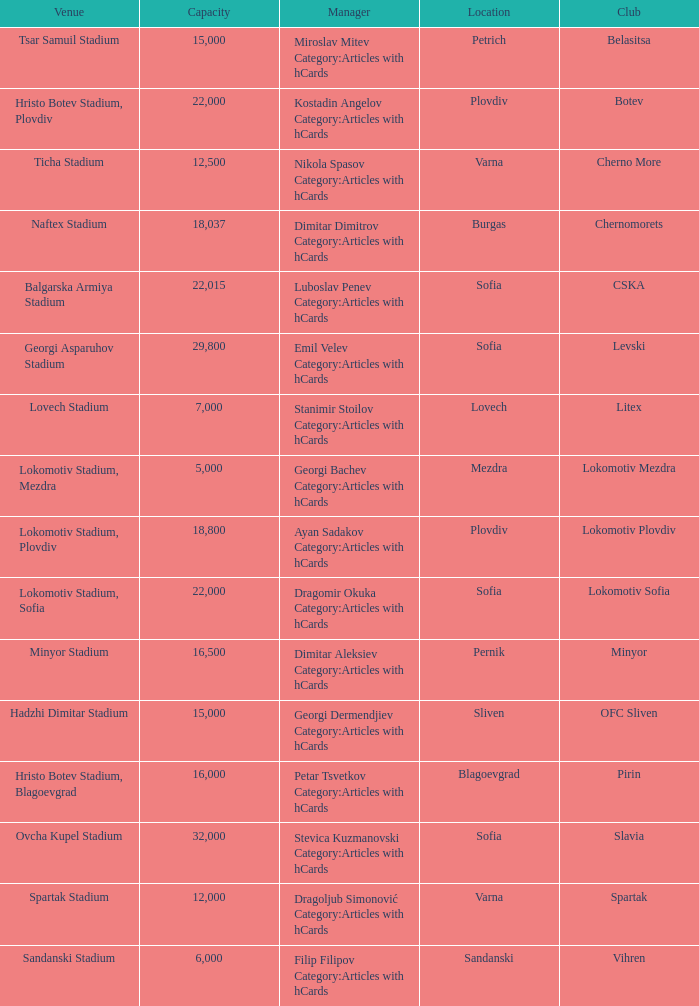What is the highest capacity for the venue, ticha stadium, located in varna? 12500.0. 